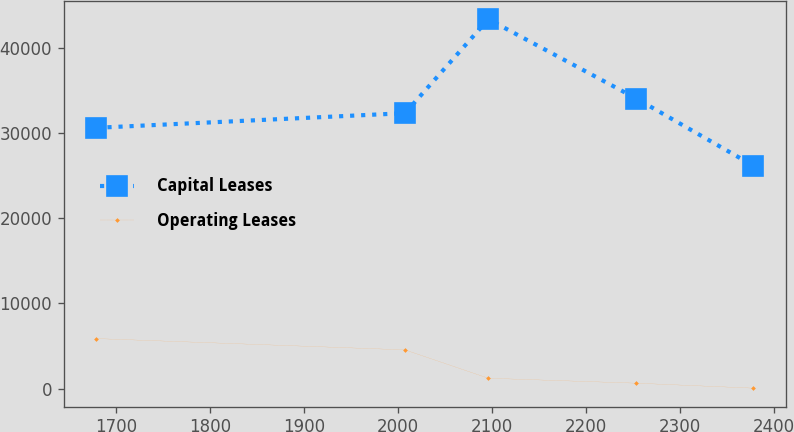Convert chart. <chart><loc_0><loc_0><loc_500><loc_500><line_chart><ecel><fcel>Capital Leases<fcel>Operating Leases<nl><fcel>1678.95<fcel>30616.9<fcel>5870.56<nl><fcel>2007.48<fcel>32334.2<fcel>4546.2<nl><fcel>2096.21<fcel>43362.6<fcel>1216.08<nl><fcel>2253.75<fcel>34051.4<fcel>634.27<nl><fcel>2377.99<fcel>26189.7<fcel>52.46<nl></chart> 